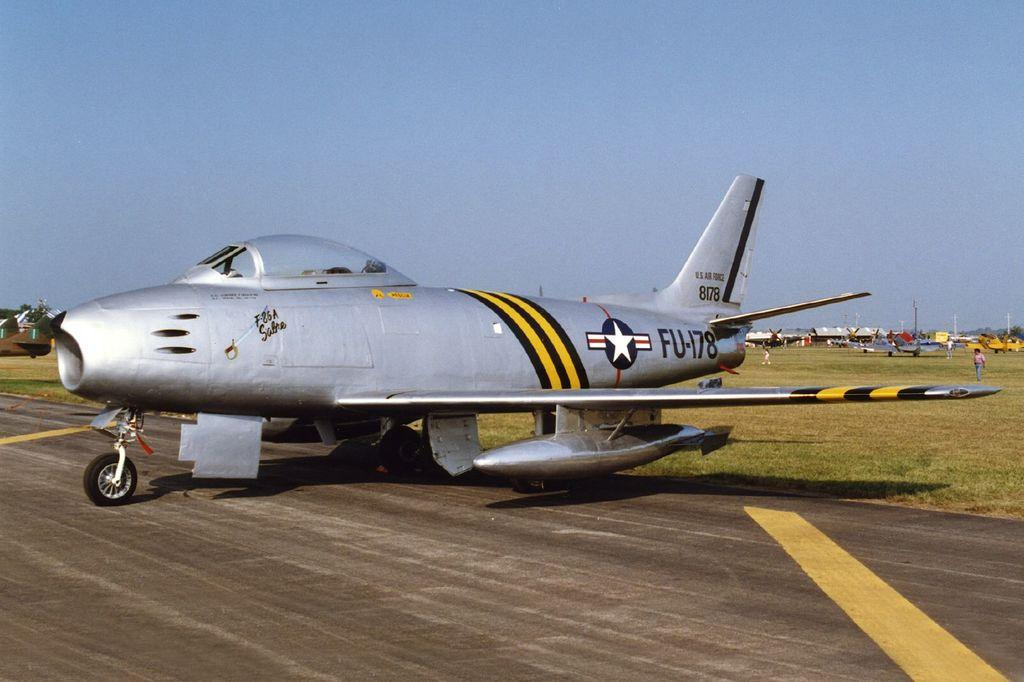<image>
Write a terse but informative summary of the picture. A US military plane with the letters: FU-178. 